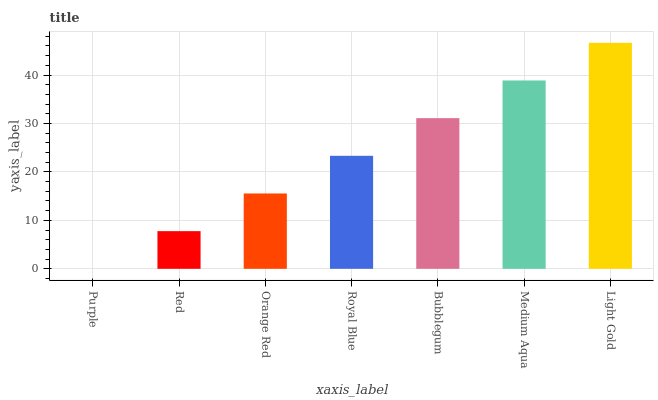Is Purple the minimum?
Answer yes or no. Yes. Is Light Gold the maximum?
Answer yes or no. Yes. Is Red the minimum?
Answer yes or no. No. Is Red the maximum?
Answer yes or no. No. Is Red greater than Purple?
Answer yes or no. Yes. Is Purple less than Red?
Answer yes or no. Yes. Is Purple greater than Red?
Answer yes or no. No. Is Red less than Purple?
Answer yes or no. No. Is Royal Blue the high median?
Answer yes or no. Yes. Is Royal Blue the low median?
Answer yes or no. Yes. Is Bubblegum the high median?
Answer yes or no. No. Is Red the low median?
Answer yes or no. No. 